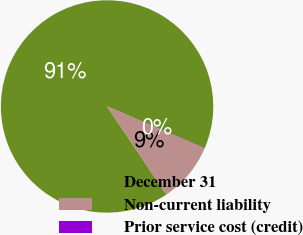Convert chart. <chart><loc_0><loc_0><loc_500><loc_500><pie_chart><fcel>December 31<fcel>Non-current liability<fcel>Prior service cost (credit)<nl><fcel>90.85%<fcel>9.12%<fcel>0.04%<nl></chart> 